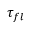Convert formula to latex. <formula><loc_0><loc_0><loc_500><loc_500>\tau _ { f l }</formula> 